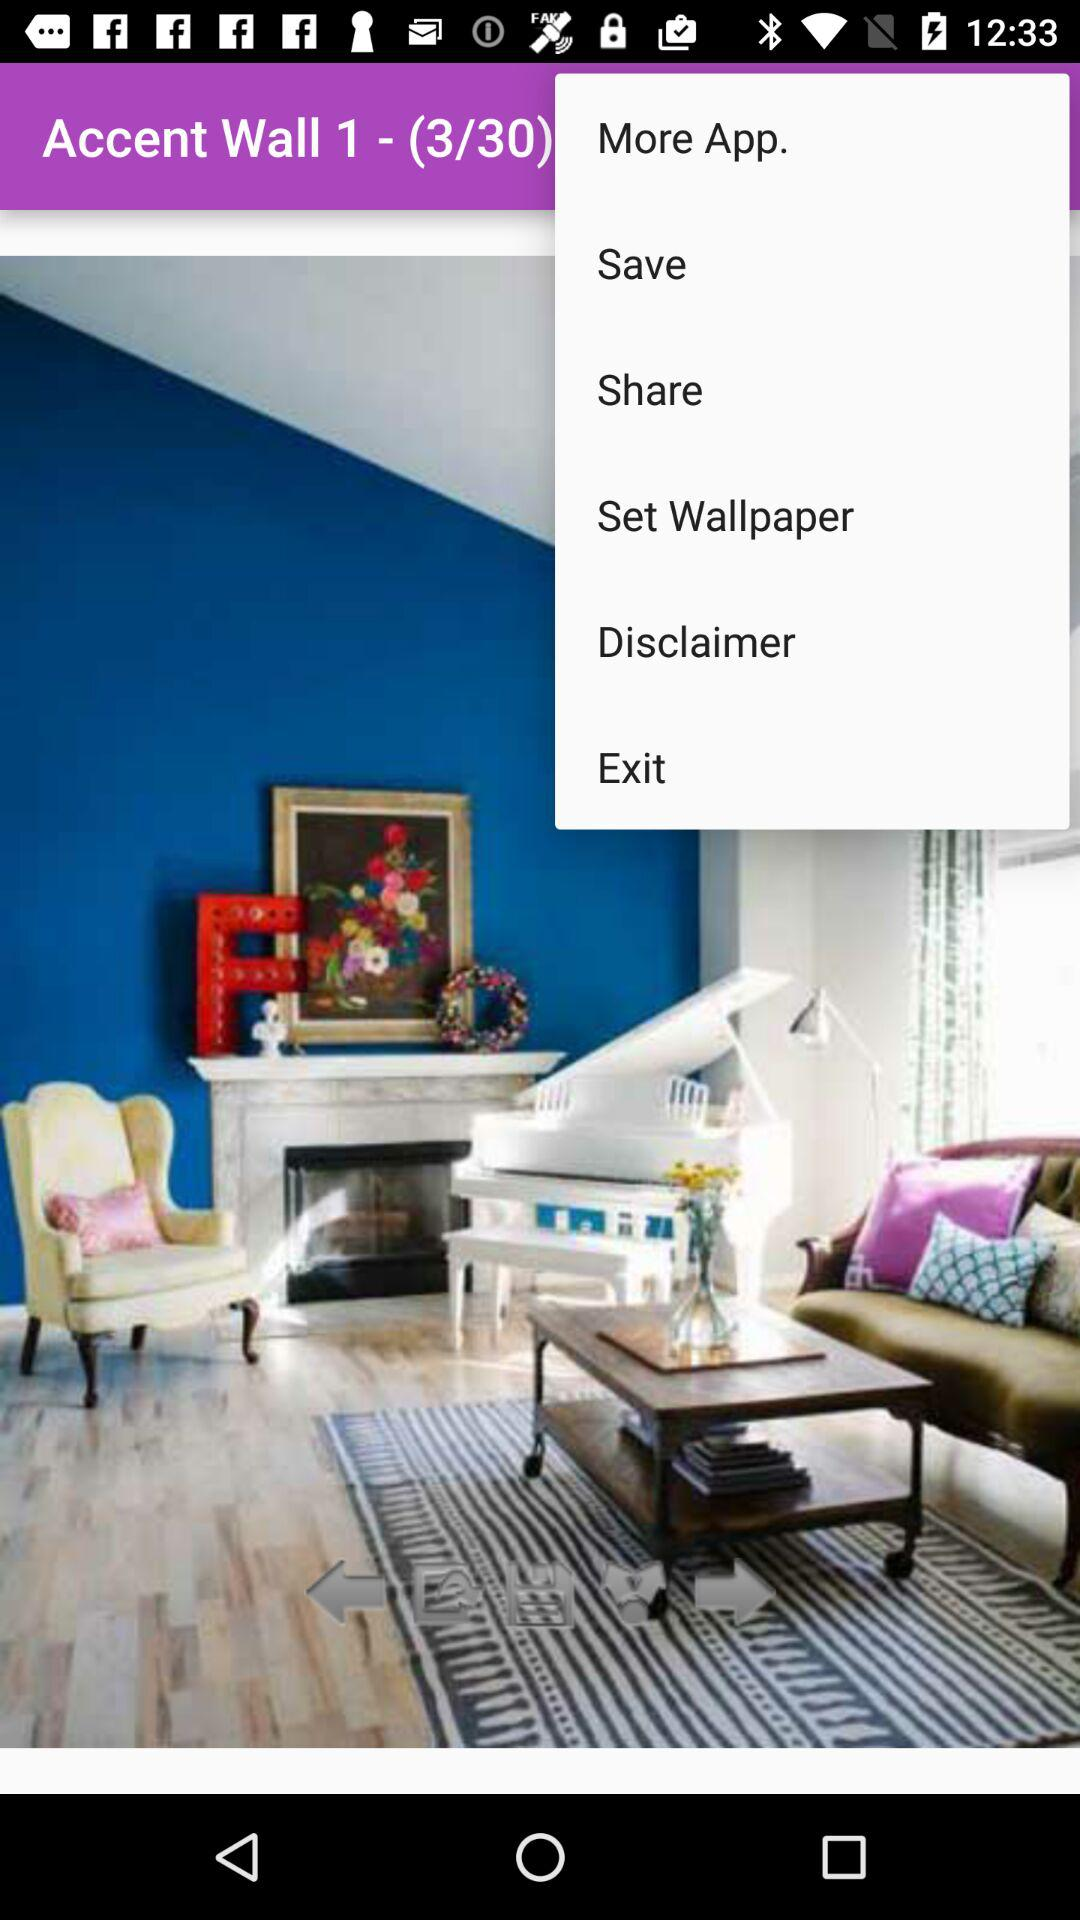What is the total number of pages in "Accent Wall 1"? The total number of pages is 30. 